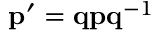Convert formula to latex. <formula><loc_0><loc_0><loc_500><loc_500>p ^ { \prime } = q p q ^ { - 1 }</formula> 